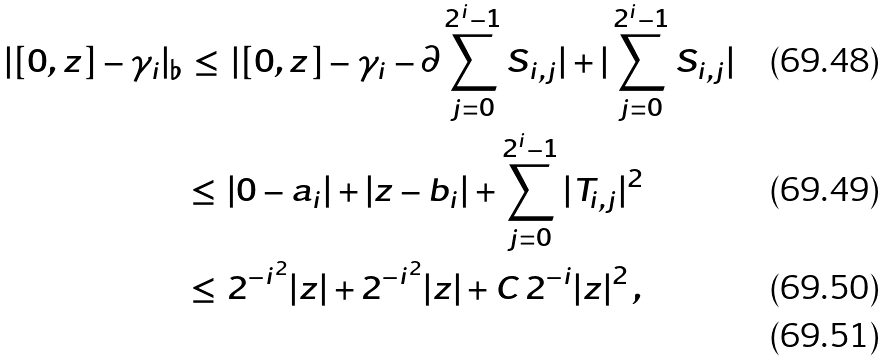Convert formula to latex. <formula><loc_0><loc_0><loc_500><loc_500>| [ 0 , z ] - \gamma _ { i } | _ { \flat } & \, \leq \, | [ 0 , z ] - \gamma _ { i } - \partial \sum _ { j = 0 } ^ { 2 ^ { i } - 1 } S _ { i , j } | + | \sum _ { j = 0 } ^ { 2 ^ { i } - 1 } S _ { i , j } | \\ & \leq \, | 0 - a _ { i } | + | z - b _ { i } | + \sum _ { j = 0 } ^ { 2 ^ { i } - 1 } | T _ { i , j } | ^ { 2 } \\ & \leq \, 2 ^ { - i ^ { 2 } } | z | + 2 ^ { - i ^ { 2 } } | z | + C \, 2 ^ { - i } | z | ^ { 2 } \, , \\</formula> 